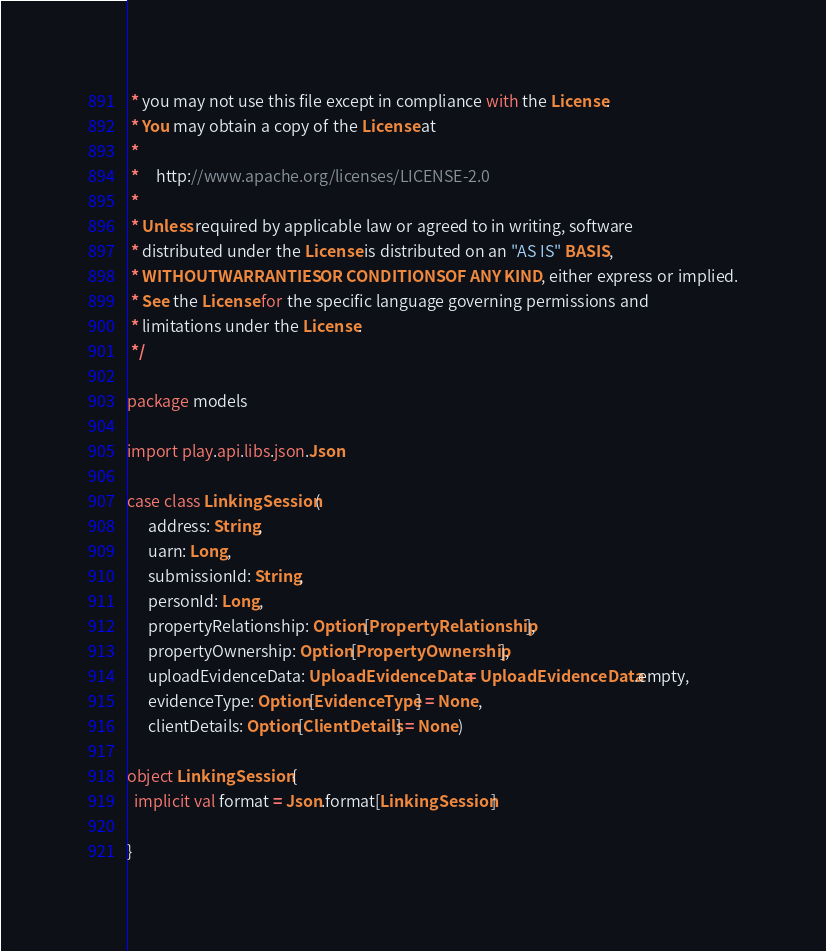Convert code to text. <code><loc_0><loc_0><loc_500><loc_500><_Scala_> * you may not use this file except in compliance with the License.
 * You may obtain a copy of the License at
 *
 *     http://www.apache.org/licenses/LICENSE-2.0
 *
 * Unless required by applicable law or agreed to in writing, software
 * distributed under the License is distributed on an "AS IS" BASIS,
 * WITHOUT WARRANTIES OR CONDITIONS OF ANY KIND, either express or implied.
 * See the License for the specific language governing permissions and
 * limitations under the License.
 */

package models

import play.api.libs.json.Json

case class LinkingSession(
      address: String,
      uarn: Long,
      submissionId: String,
      personId: Long,
      propertyRelationship: Option[PropertyRelationship],
      propertyOwnership: Option[PropertyOwnership],
      uploadEvidenceData: UploadEvidenceData = UploadEvidenceData.empty,
      evidenceType: Option[EvidenceType] = None,
      clientDetails: Option[ClientDetails] = None)

object LinkingSession {
  implicit val format = Json.format[LinkingSession]

}
</code> 